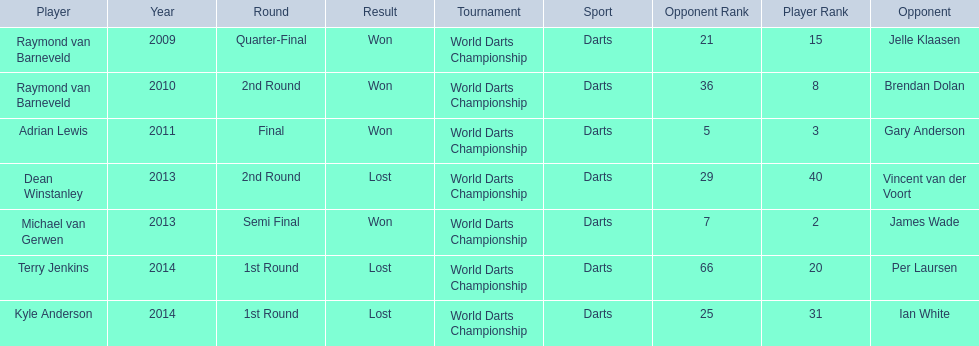Who are the players listed? Raymond van Barneveld, Raymond van Barneveld, Adrian Lewis, Dean Winstanley, Michael van Gerwen, Terry Jenkins, Kyle Anderson. Which of these players played in 2011? Adrian Lewis. 